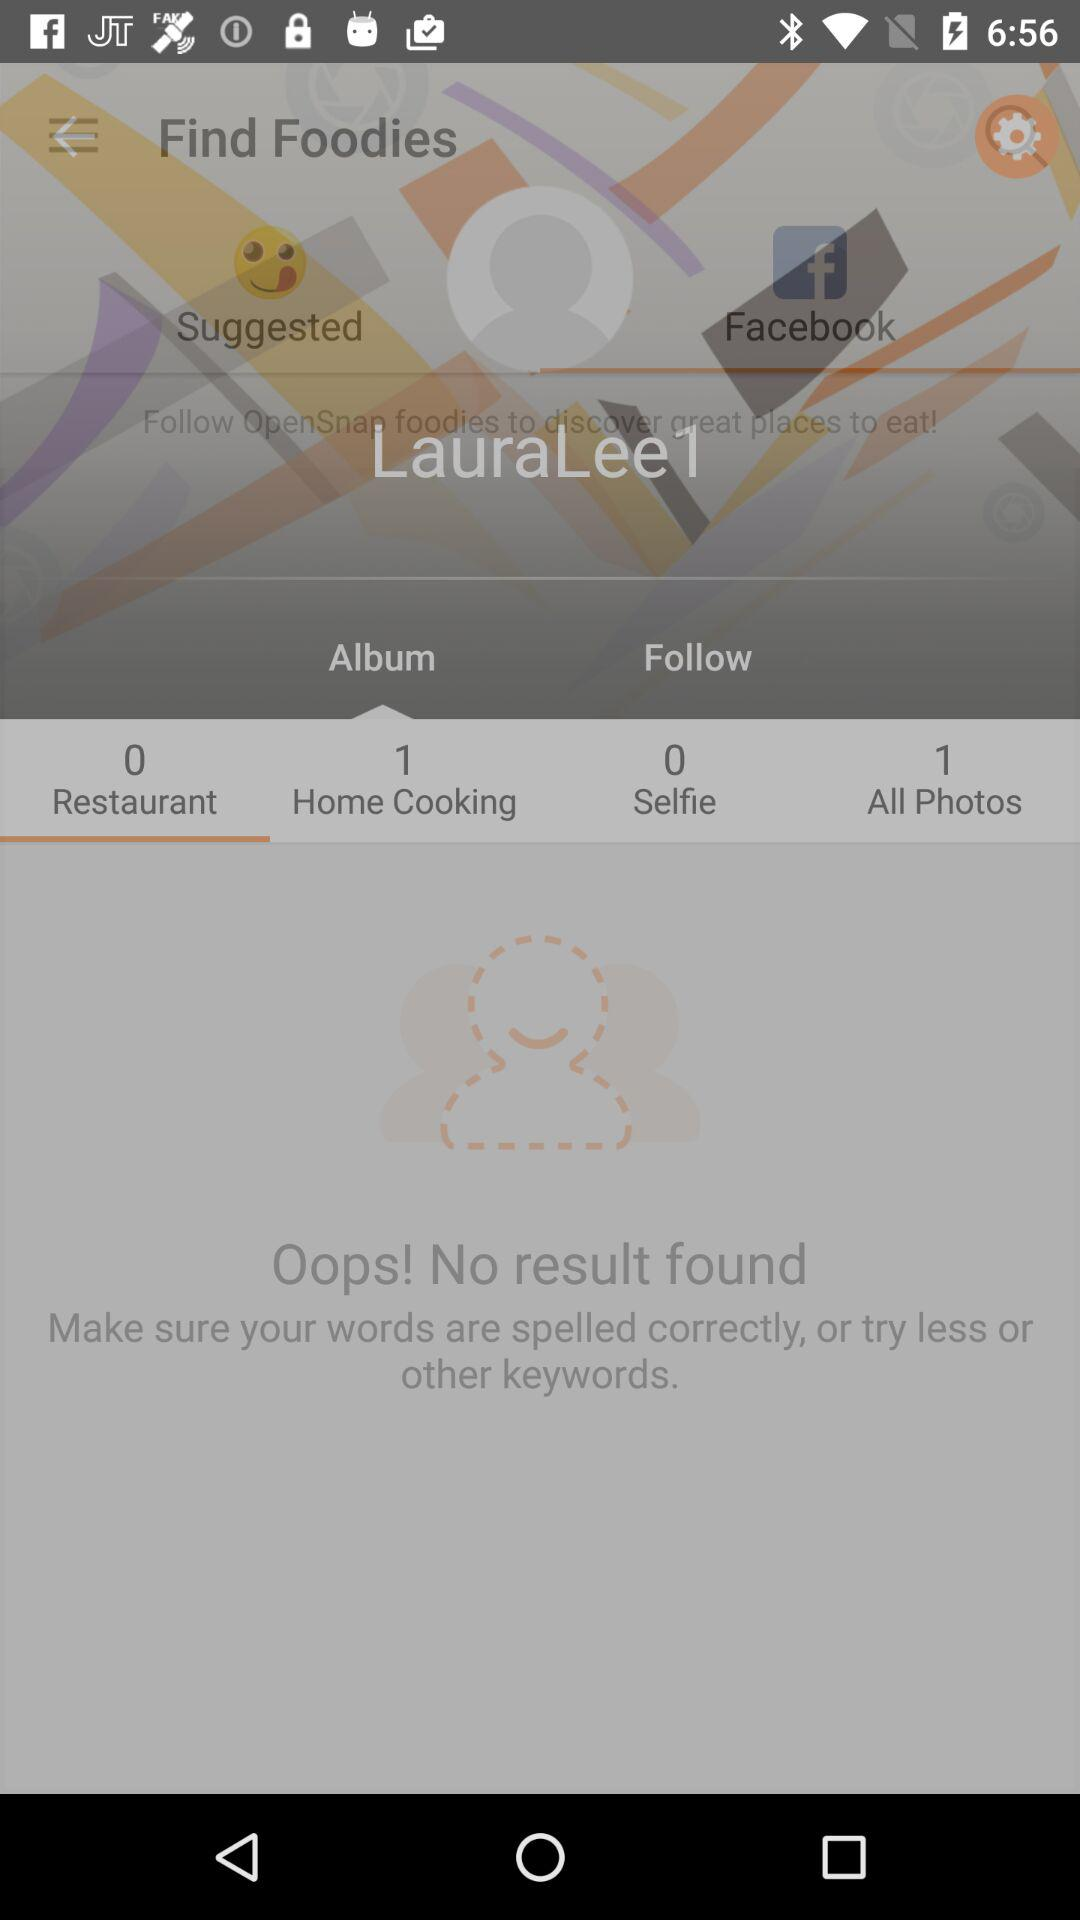What is the username? The username is "LauraLee1". 